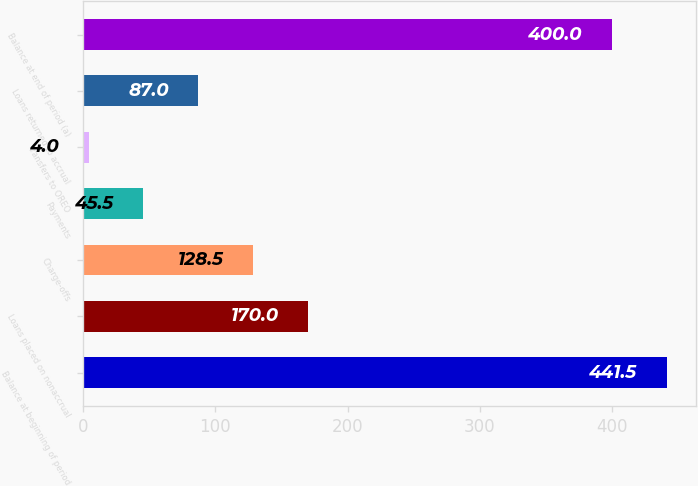<chart> <loc_0><loc_0><loc_500><loc_500><bar_chart><fcel>Balance at beginning of period<fcel>Loans placed on nonaccrual<fcel>Charge-offs<fcel>Payments<fcel>Transfers to OREO<fcel>Loans returned to accrual<fcel>Balance at end of period (a)<nl><fcel>441.5<fcel>170<fcel>128.5<fcel>45.5<fcel>4<fcel>87<fcel>400<nl></chart> 